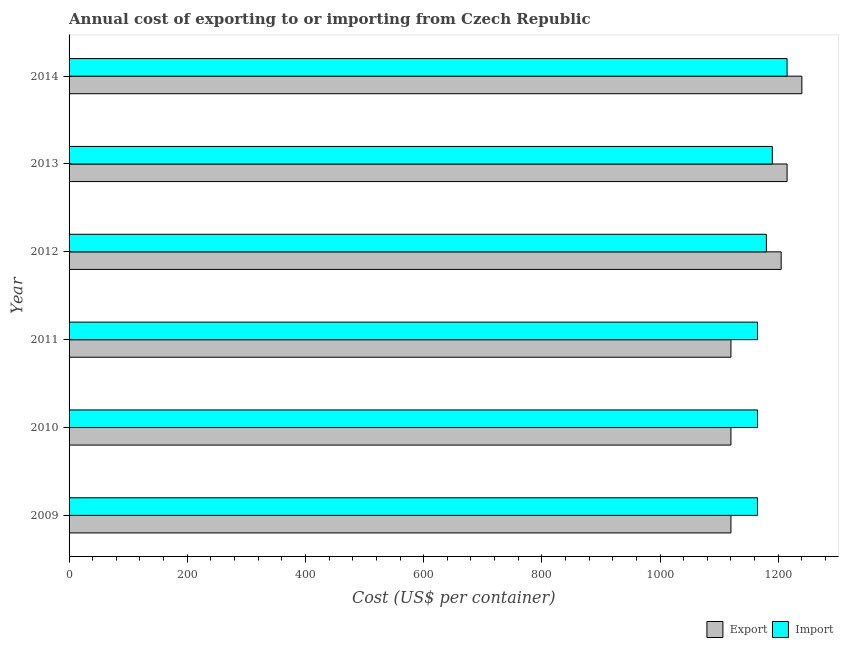How many different coloured bars are there?
Provide a succinct answer. 2. Are the number of bars on each tick of the Y-axis equal?
Make the answer very short. Yes. How many bars are there on the 5th tick from the top?
Keep it short and to the point. 2. How many bars are there on the 5th tick from the bottom?
Offer a terse response. 2. What is the label of the 1st group of bars from the top?
Your response must be concise. 2014. What is the export cost in 2010?
Make the answer very short. 1120. Across all years, what is the maximum export cost?
Offer a very short reply. 1240. Across all years, what is the minimum export cost?
Ensure brevity in your answer.  1120. In which year was the export cost maximum?
Ensure brevity in your answer.  2014. What is the total import cost in the graph?
Your response must be concise. 7080. What is the difference between the import cost in 2009 and that in 2010?
Give a very brief answer. 0. What is the difference between the export cost in 2014 and the import cost in 2010?
Make the answer very short. 75. What is the average import cost per year?
Provide a short and direct response. 1180. In the year 2009, what is the difference between the export cost and import cost?
Provide a succinct answer. -45. In how many years, is the export cost greater than 280 US$?
Give a very brief answer. 6. Is the difference between the export cost in 2009 and 2014 greater than the difference between the import cost in 2009 and 2014?
Offer a very short reply. No. What is the difference between the highest and the lowest export cost?
Give a very brief answer. 120. In how many years, is the export cost greater than the average export cost taken over all years?
Your answer should be compact. 3. What does the 2nd bar from the top in 2014 represents?
Make the answer very short. Export. What does the 1st bar from the bottom in 2012 represents?
Ensure brevity in your answer.  Export. Are the values on the major ticks of X-axis written in scientific E-notation?
Provide a succinct answer. No. Does the graph contain any zero values?
Your answer should be compact. No. Does the graph contain grids?
Your answer should be very brief. No. How many legend labels are there?
Provide a succinct answer. 2. How are the legend labels stacked?
Your answer should be very brief. Horizontal. What is the title of the graph?
Your answer should be very brief. Annual cost of exporting to or importing from Czech Republic. What is the label or title of the X-axis?
Offer a very short reply. Cost (US$ per container). What is the label or title of the Y-axis?
Provide a short and direct response. Year. What is the Cost (US$ per container) in Export in 2009?
Provide a succinct answer. 1120. What is the Cost (US$ per container) of Import in 2009?
Your response must be concise. 1165. What is the Cost (US$ per container) of Export in 2010?
Offer a terse response. 1120. What is the Cost (US$ per container) of Import in 2010?
Your response must be concise. 1165. What is the Cost (US$ per container) in Export in 2011?
Your answer should be compact. 1120. What is the Cost (US$ per container) in Import in 2011?
Offer a very short reply. 1165. What is the Cost (US$ per container) in Export in 2012?
Offer a very short reply. 1205. What is the Cost (US$ per container) of Import in 2012?
Your answer should be compact. 1180. What is the Cost (US$ per container) in Export in 2013?
Your answer should be compact. 1215. What is the Cost (US$ per container) in Import in 2013?
Keep it short and to the point. 1190. What is the Cost (US$ per container) of Export in 2014?
Offer a very short reply. 1240. What is the Cost (US$ per container) of Import in 2014?
Your answer should be compact. 1215. Across all years, what is the maximum Cost (US$ per container) of Export?
Provide a succinct answer. 1240. Across all years, what is the maximum Cost (US$ per container) in Import?
Give a very brief answer. 1215. Across all years, what is the minimum Cost (US$ per container) of Export?
Your response must be concise. 1120. Across all years, what is the minimum Cost (US$ per container) of Import?
Your response must be concise. 1165. What is the total Cost (US$ per container) in Export in the graph?
Offer a terse response. 7020. What is the total Cost (US$ per container) in Import in the graph?
Your answer should be very brief. 7080. What is the difference between the Cost (US$ per container) of Export in 2009 and that in 2010?
Keep it short and to the point. 0. What is the difference between the Cost (US$ per container) of Import in 2009 and that in 2011?
Keep it short and to the point. 0. What is the difference between the Cost (US$ per container) in Export in 2009 and that in 2012?
Provide a short and direct response. -85. What is the difference between the Cost (US$ per container) in Import in 2009 and that in 2012?
Keep it short and to the point. -15. What is the difference between the Cost (US$ per container) in Export in 2009 and that in 2013?
Give a very brief answer. -95. What is the difference between the Cost (US$ per container) in Export in 2009 and that in 2014?
Provide a short and direct response. -120. What is the difference between the Cost (US$ per container) of Import in 2009 and that in 2014?
Your response must be concise. -50. What is the difference between the Cost (US$ per container) in Import in 2010 and that in 2011?
Keep it short and to the point. 0. What is the difference between the Cost (US$ per container) of Export in 2010 and that in 2012?
Offer a terse response. -85. What is the difference between the Cost (US$ per container) of Import in 2010 and that in 2012?
Your response must be concise. -15. What is the difference between the Cost (US$ per container) of Export in 2010 and that in 2013?
Provide a succinct answer. -95. What is the difference between the Cost (US$ per container) in Import in 2010 and that in 2013?
Keep it short and to the point. -25. What is the difference between the Cost (US$ per container) in Export in 2010 and that in 2014?
Provide a short and direct response. -120. What is the difference between the Cost (US$ per container) in Import in 2010 and that in 2014?
Offer a very short reply. -50. What is the difference between the Cost (US$ per container) of Export in 2011 and that in 2012?
Give a very brief answer. -85. What is the difference between the Cost (US$ per container) of Export in 2011 and that in 2013?
Your answer should be very brief. -95. What is the difference between the Cost (US$ per container) of Import in 2011 and that in 2013?
Ensure brevity in your answer.  -25. What is the difference between the Cost (US$ per container) in Export in 2011 and that in 2014?
Your answer should be compact. -120. What is the difference between the Cost (US$ per container) of Import in 2011 and that in 2014?
Your response must be concise. -50. What is the difference between the Cost (US$ per container) in Import in 2012 and that in 2013?
Give a very brief answer. -10. What is the difference between the Cost (US$ per container) in Export in 2012 and that in 2014?
Give a very brief answer. -35. What is the difference between the Cost (US$ per container) in Import in 2012 and that in 2014?
Provide a succinct answer. -35. What is the difference between the Cost (US$ per container) in Import in 2013 and that in 2014?
Provide a short and direct response. -25. What is the difference between the Cost (US$ per container) in Export in 2009 and the Cost (US$ per container) in Import in 2010?
Make the answer very short. -45. What is the difference between the Cost (US$ per container) of Export in 2009 and the Cost (US$ per container) of Import in 2011?
Make the answer very short. -45. What is the difference between the Cost (US$ per container) in Export in 2009 and the Cost (US$ per container) in Import in 2012?
Provide a short and direct response. -60. What is the difference between the Cost (US$ per container) in Export in 2009 and the Cost (US$ per container) in Import in 2013?
Provide a succinct answer. -70. What is the difference between the Cost (US$ per container) of Export in 2009 and the Cost (US$ per container) of Import in 2014?
Your answer should be compact. -95. What is the difference between the Cost (US$ per container) of Export in 2010 and the Cost (US$ per container) of Import in 2011?
Provide a short and direct response. -45. What is the difference between the Cost (US$ per container) in Export in 2010 and the Cost (US$ per container) in Import in 2012?
Offer a terse response. -60. What is the difference between the Cost (US$ per container) of Export in 2010 and the Cost (US$ per container) of Import in 2013?
Your response must be concise. -70. What is the difference between the Cost (US$ per container) of Export in 2010 and the Cost (US$ per container) of Import in 2014?
Your answer should be compact. -95. What is the difference between the Cost (US$ per container) of Export in 2011 and the Cost (US$ per container) of Import in 2012?
Your response must be concise. -60. What is the difference between the Cost (US$ per container) of Export in 2011 and the Cost (US$ per container) of Import in 2013?
Provide a short and direct response. -70. What is the difference between the Cost (US$ per container) in Export in 2011 and the Cost (US$ per container) in Import in 2014?
Make the answer very short. -95. What is the difference between the Cost (US$ per container) of Export in 2012 and the Cost (US$ per container) of Import in 2014?
Your answer should be very brief. -10. What is the average Cost (US$ per container) of Export per year?
Your answer should be very brief. 1170. What is the average Cost (US$ per container) of Import per year?
Ensure brevity in your answer.  1180. In the year 2009, what is the difference between the Cost (US$ per container) of Export and Cost (US$ per container) of Import?
Provide a short and direct response. -45. In the year 2010, what is the difference between the Cost (US$ per container) in Export and Cost (US$ per container) in Import?
Offer a very short reply. -45. In the year 2011, what is the difference between the Cost (US$ per container) of Export and Cost (US$ per container) of Import?
Provide a short and direct response. -45. What is the ratio of the Cost (US$ per container) in Export in 2009 to that in 2010?
Offer a very short reply. 1. What is the ratio of the Cost (US$ per container) of Export in 2009 to that in 2011?
Provide a short and direct response. 1. What is the ratio of the Cost (US$ per container) in Export in 2009 to that in 2012?
Ensure brevity in your answer.  0.93. What is the ratio of the Cost (US$ per container) of Import in 2009 to that in 2012?
Your response must be concise. 0.99. What is the ratio of the Cost (US$ per container) of Export in 2009 to that in 2013?
Give a very brief answer. 0.92. What is the ratio of the Cost (US$ per container) of Import in 2009 to that in 2013?
Your answer should be compact. 0.98. What is the ratio of the Cost (US$ per container) in Export in 2009 to that in 2014?
Your response must be concise. 0.9. What is the ratio of the Cost (US$ per container) of Import in 2009 to that in 2014?
Your answer should be very brief. 0.96. What is the ratio of the Cost (US$ per container) of Export in 2010 to that in 2011?
Ensure brevity in your answer.  1. What is the ratio of the Cost (US$ per container) in Import in 2010 to that in 2011?
Ensure brevity in your answer.  1. What is the ratio of the Cost (US$ per container) of Export in 2010 to that in 2012?
Keep it short and to the point. 0.93. What is the ratio of the Cost (US$ per container) in Import in 2010 to that in 2012?
Provide a short and direct response. 0.99. What is the ratio of the Cost (US$ per container) of Export in 2010 to that in 2013?
Your answer should be compact. 0.92. What is the ratio of the Cost (US$ per container) in Export in 2010 to that in 2014?
Provide a succinct answer. 0.9. What is the ratio of the Cost (US$ per container) in Import in 2010 to that in 2014?
Offer a terse response. 0.96. What is the ratio of the Cost (US$ per container) of Export in 2011 to that in 2012?
Your response must be concise. 0.93. What is the ratio of the Cost (US$ per container) of Import in 2011 to that in 2012?
Make the answer very short. 0.99. What is the ratio of the Cost (US$ per container) of Export in 2011 to that in 2013?
Your answer should be very brief. 0.92. What is the ratio of the Cost (US$ per container) of Export in 2011 to that in 2014?
Ensure brevity in your answer.  0.9. What is the ratio of the Cost (US$ per container) in Import in 2011 to that in 2014?
Your answer should be very brief. 0.96. What is the ratio of the Cost (US$ per container) of Export in 2012 to that in 2014?
Your response must be concise. 0.97. What is the ratio of the Cost (US$ per container) in Import in 2012 to that in 2014?
Provide a succinct answer. 0.97. What is the ratio of the Cost (US$ per container) of Export in 2013 to that in 2014?
Make the answer very short. 0.98. What is the ratio of the Cost (US$ per container) of Import in 2013 to that in 2014?
Offer a terse response. 0.98. What is the difference between the highest and the second highest Cost (US$ per container) of Import?
Make the answer very short. 25. What is the difference between the highest and the lowest Cost (US$ per container) of Export?
Provide a short and direct response. 120. What is the difference between the highest and the lowest Cost (US$ per container) of Import?
Provide a short and direct response. 50. 